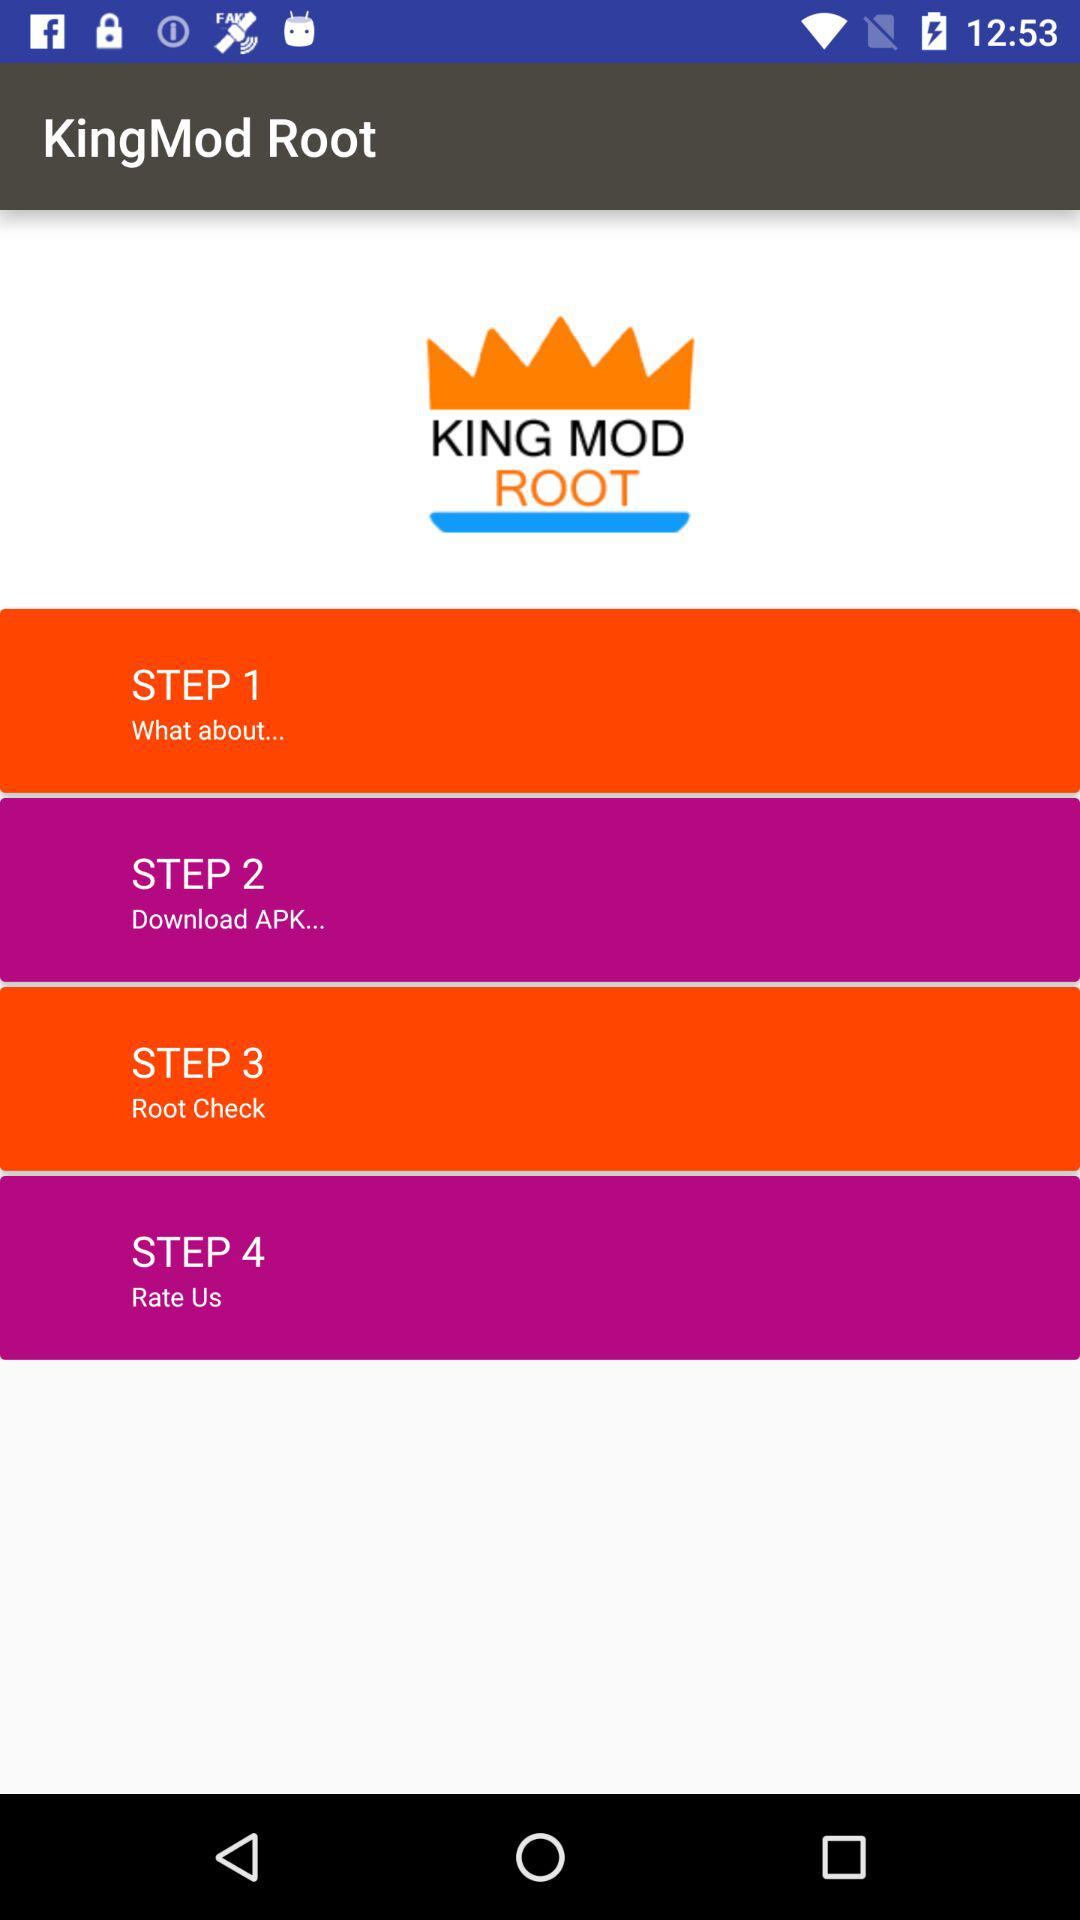How many steps in the king mod root?
When the provided information is insufficient, respond with <no answer>. <no answer> 